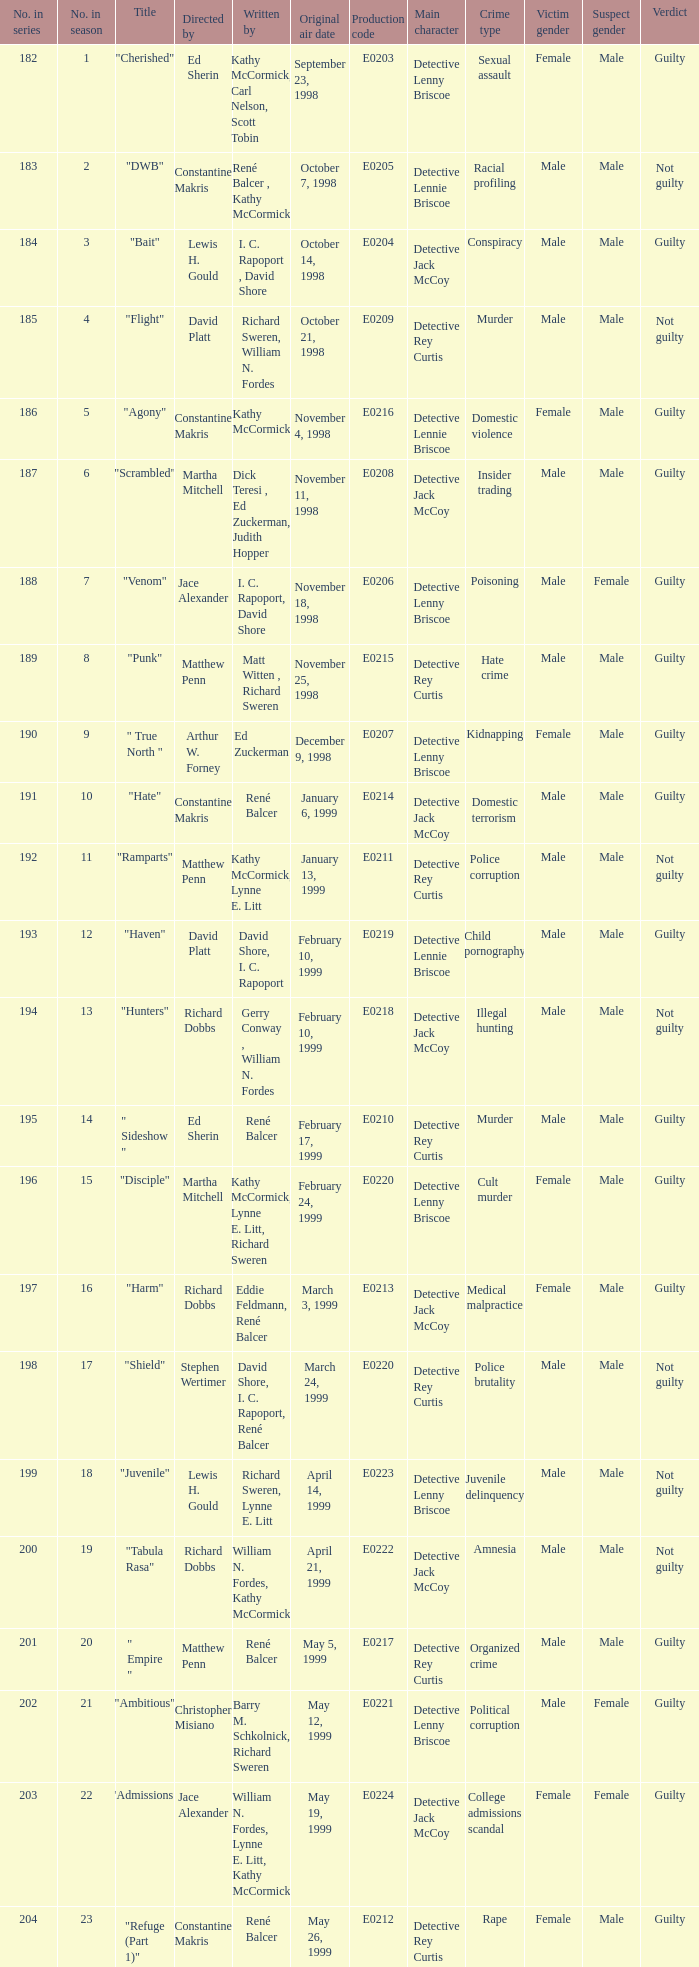The episode with the production code E0208 is directed by who? Martha Mitchell. 